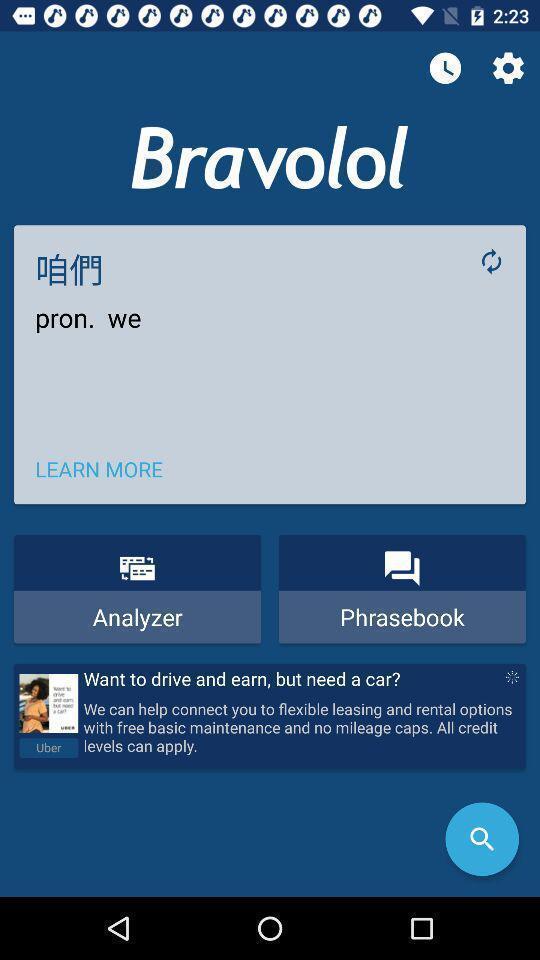Describe the content in this image. Screen showing page of an translator application. 